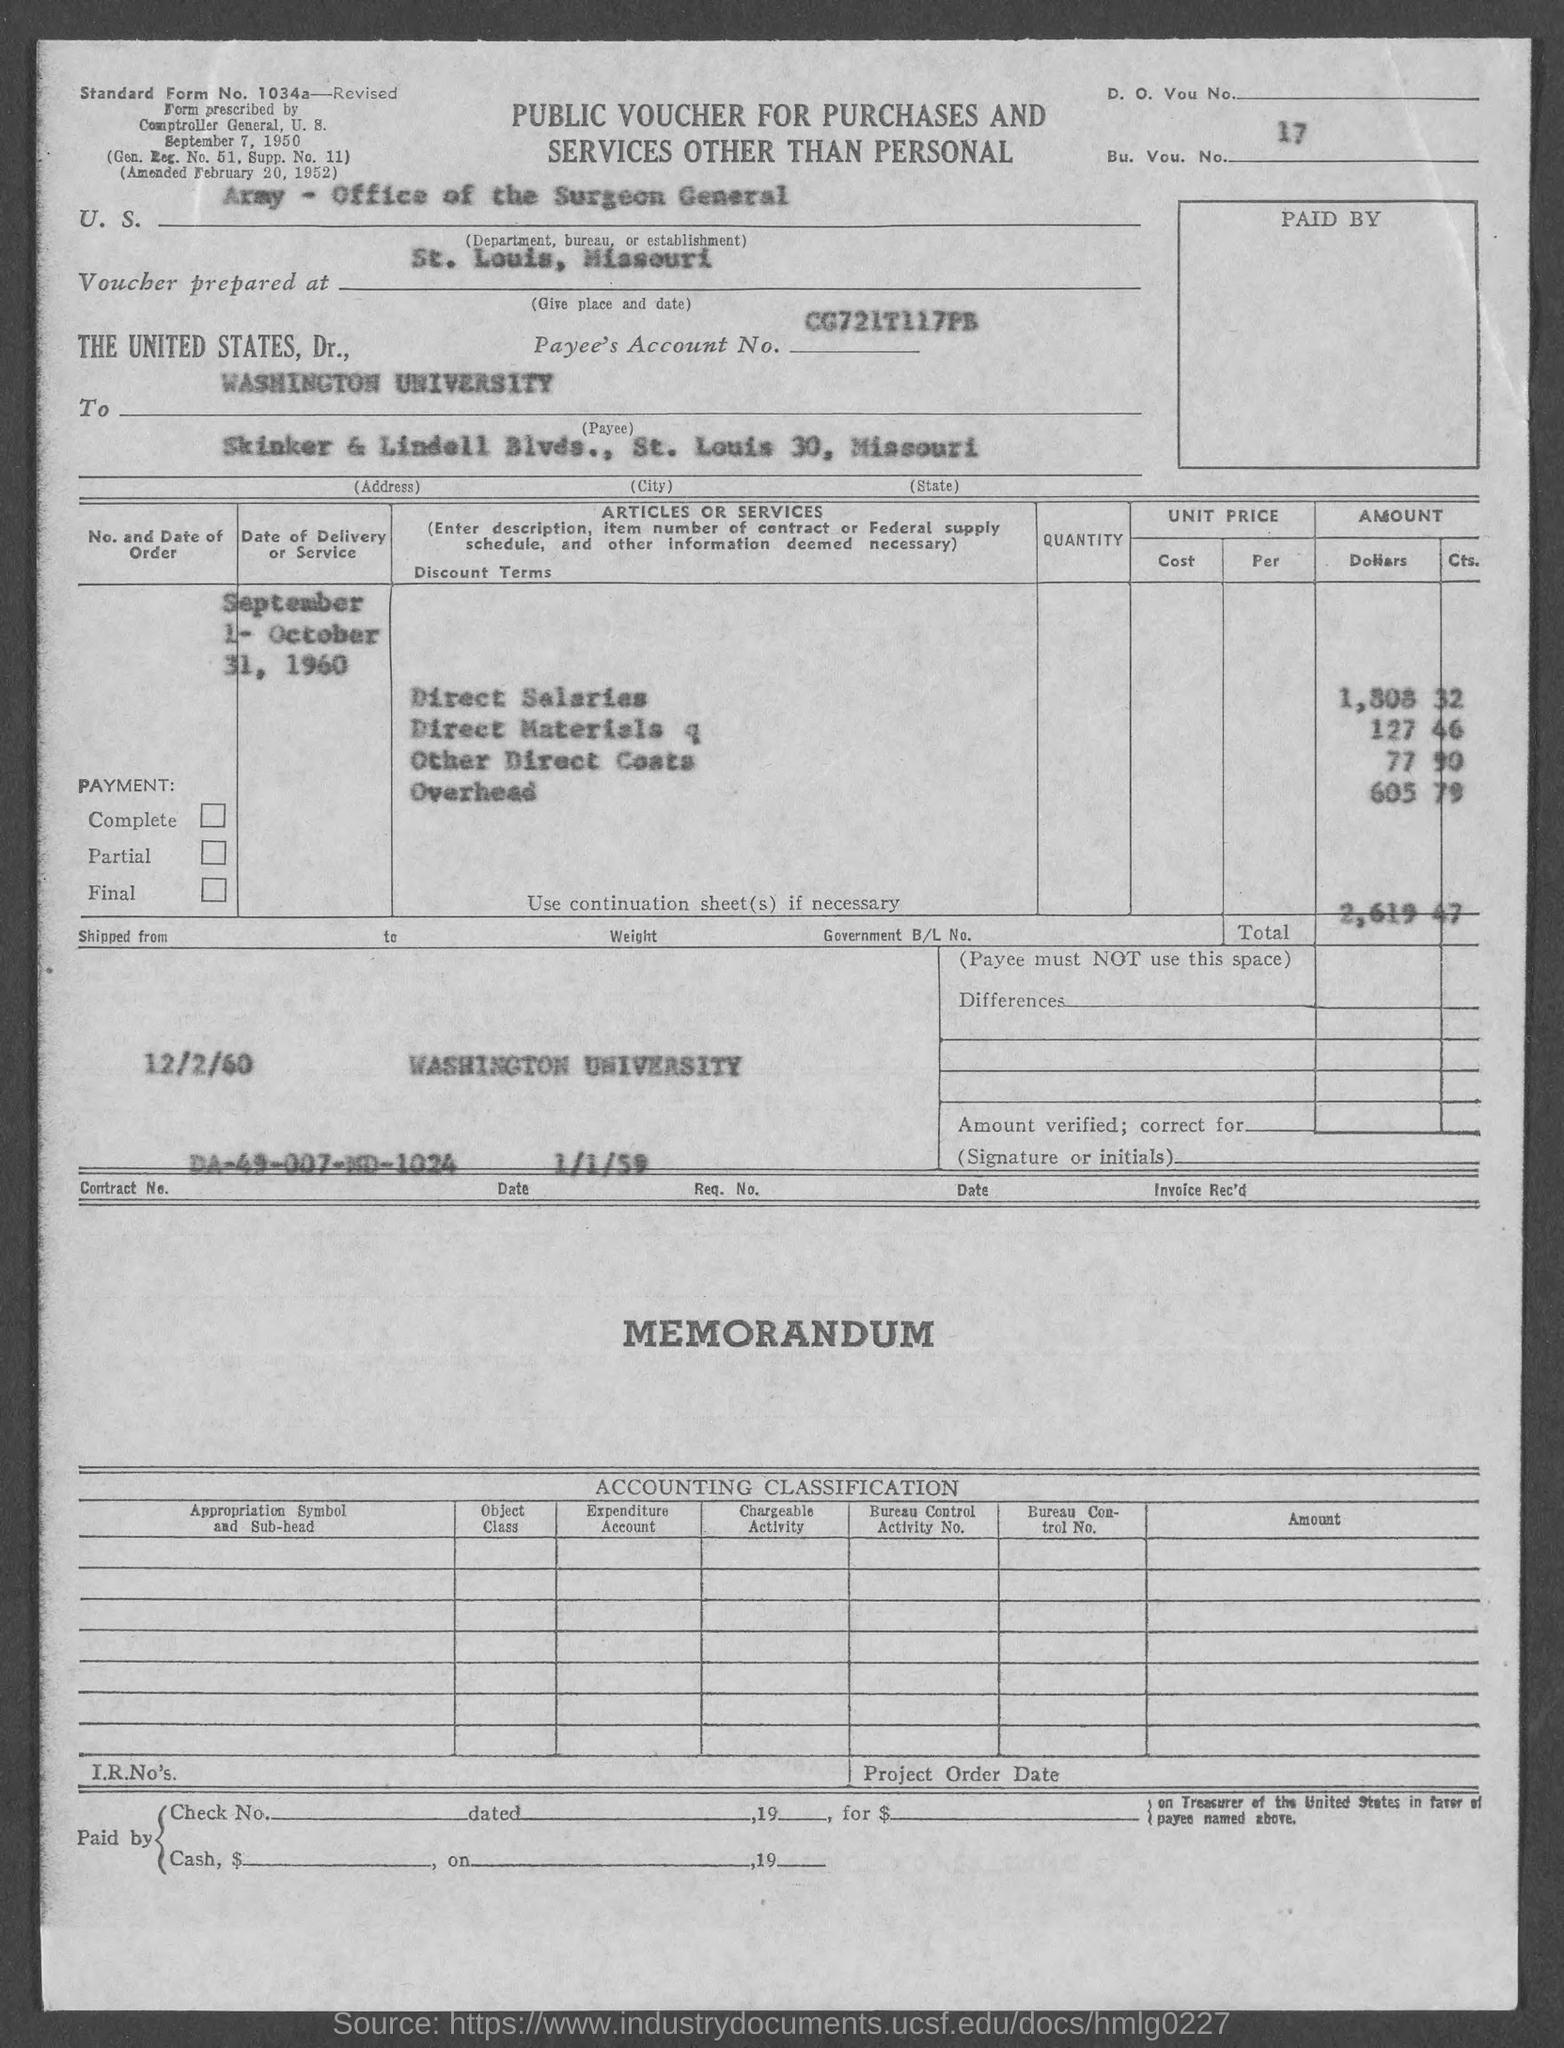What is the bu. vou. no.?
Offer a terse response. 17. In which state is washington university at?
Offer a terse response. Missouri. What is the standard form no.?
Ensure brevity in your answer.  1034a. What is the total?
Your answer should be compact. 2,619.47. What is the amount of direct salaries ?
Offer a very short reply. 1,808 32. What is the amount of direct materials ?
Your answer should be compact. 127 46. What is the amount of other direct costs?
Your answer should be very brief. 77 90. What is the amount of overhead ?
Give a very brief answer. 605 79. What is the contract no.?
Offer a terse response. DA-49-007-MD-1024. In which state is voucher prepared at ?
Keep it short and to the point. Missouri. 